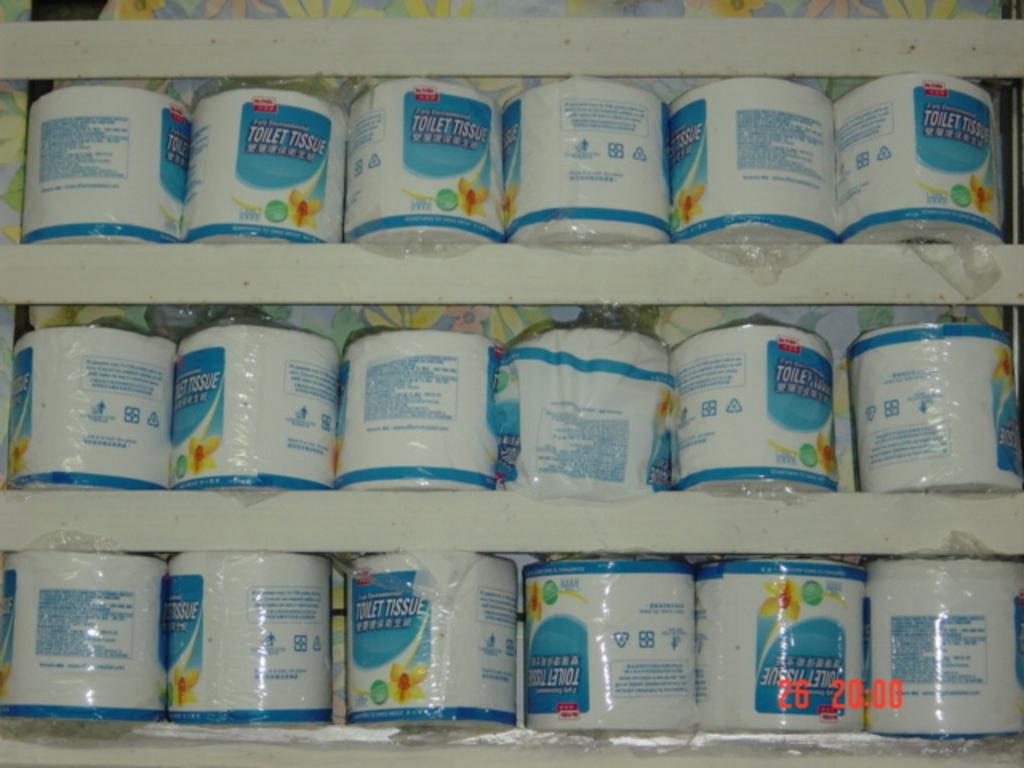What type of paper product is this?
Offer a very short reply. Toilet tissue. 